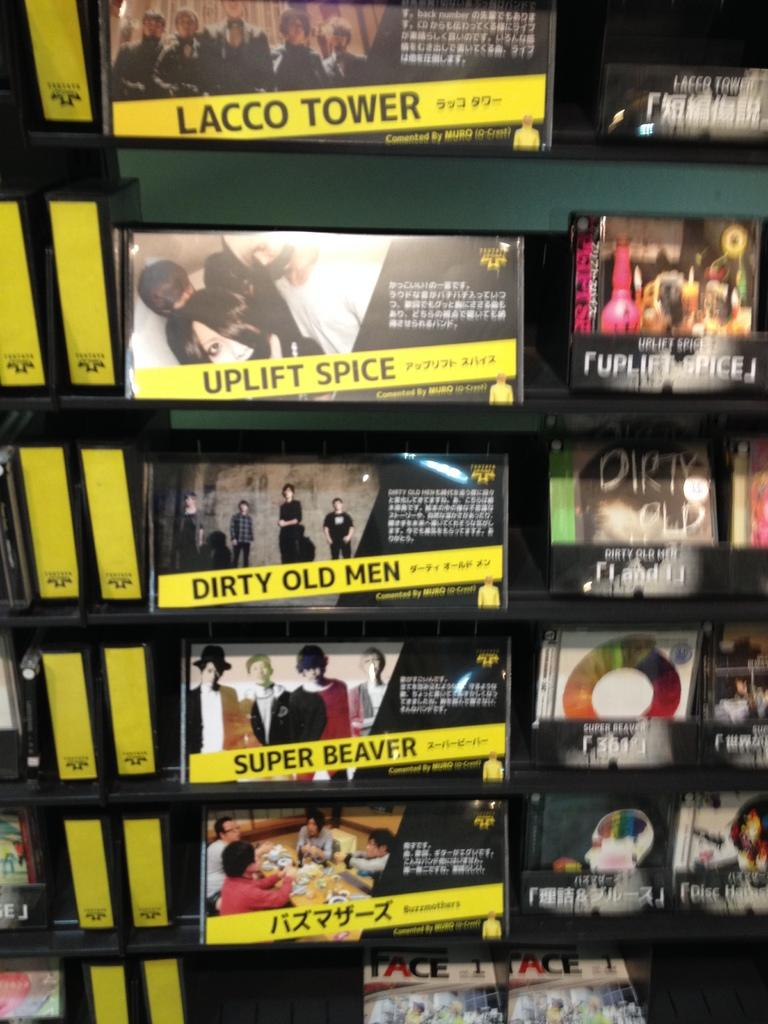<image>
Describe the image concisely. Many shelves of music CDs with the group Lacco Tower displayed on the top shelf. 